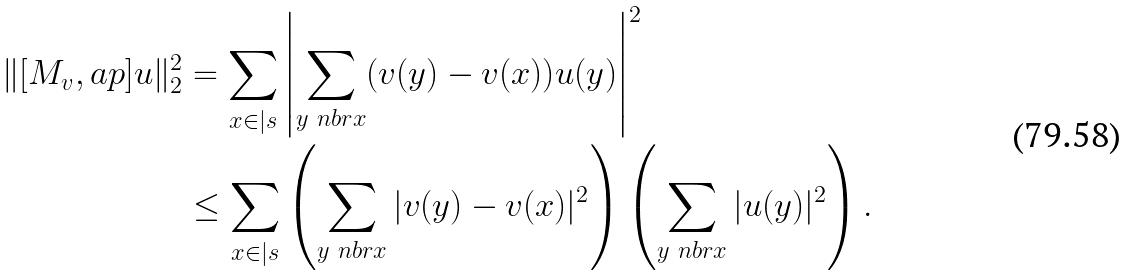<formula> <loc_0><loc_0><loc_500><loc_500>\| [ M _ { v } , \L a p ] u \| _ { 2 } ^ { 2 } & = \sum _ { x \in | s } \left | \sum _ { y \ n b r x } ( v ( y ) - v ( x ) ) u ( y ) \right | ^ { 2 } \\ & \leq \sum _ { x \in | s } \left ( \sum _ { y \ n b r x } | v ( y ) - v ( x ) | ^ { 2 } \right ) \left ( \sum _ { y \ n b r x } | u ( y ) | ^ { 2 } \right ) .</formula> 